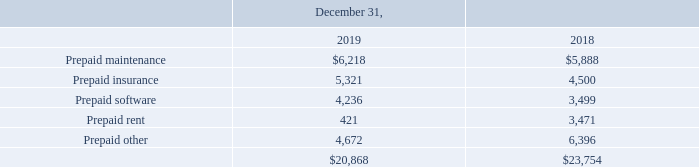Note 10. Prepaid Expenses
Prepaid expenses consisted of the following (in thousands):
What was the amount of prepaid expenses in 2019?
Answer scale should be: thousand. $20,868. What was the amount of Prepaid maintenance in 2018?
Answer scale should be: thousand. $5,888. What are the items considered under prepaid expenses in the table? Prepaid maintenance, prepaid insurance, prepaid software, prepaid rent, prepaid other. In which year was the amount of prepaid insurance larger? 5,321>4,500
Answer: 2019. What was the change in prepaid insurance in 2019 from 2018?
Answer scale should be: thousand. 5,321-4,500
Answer: 821. What was the percentage change in prepaid insurance in 2019 from 2018?
Answer scale should be: percent. (5,321-4,500)/4,500
Answer: 18.24. 